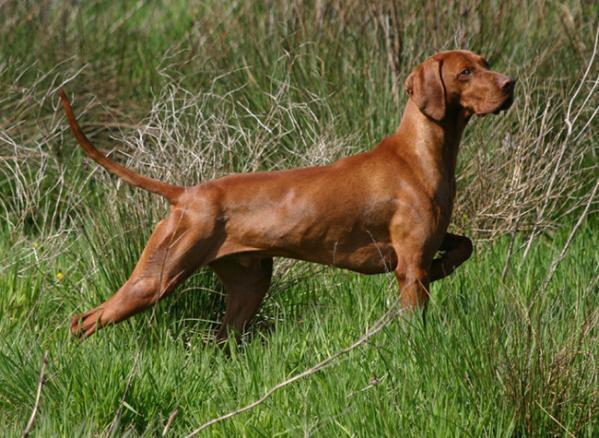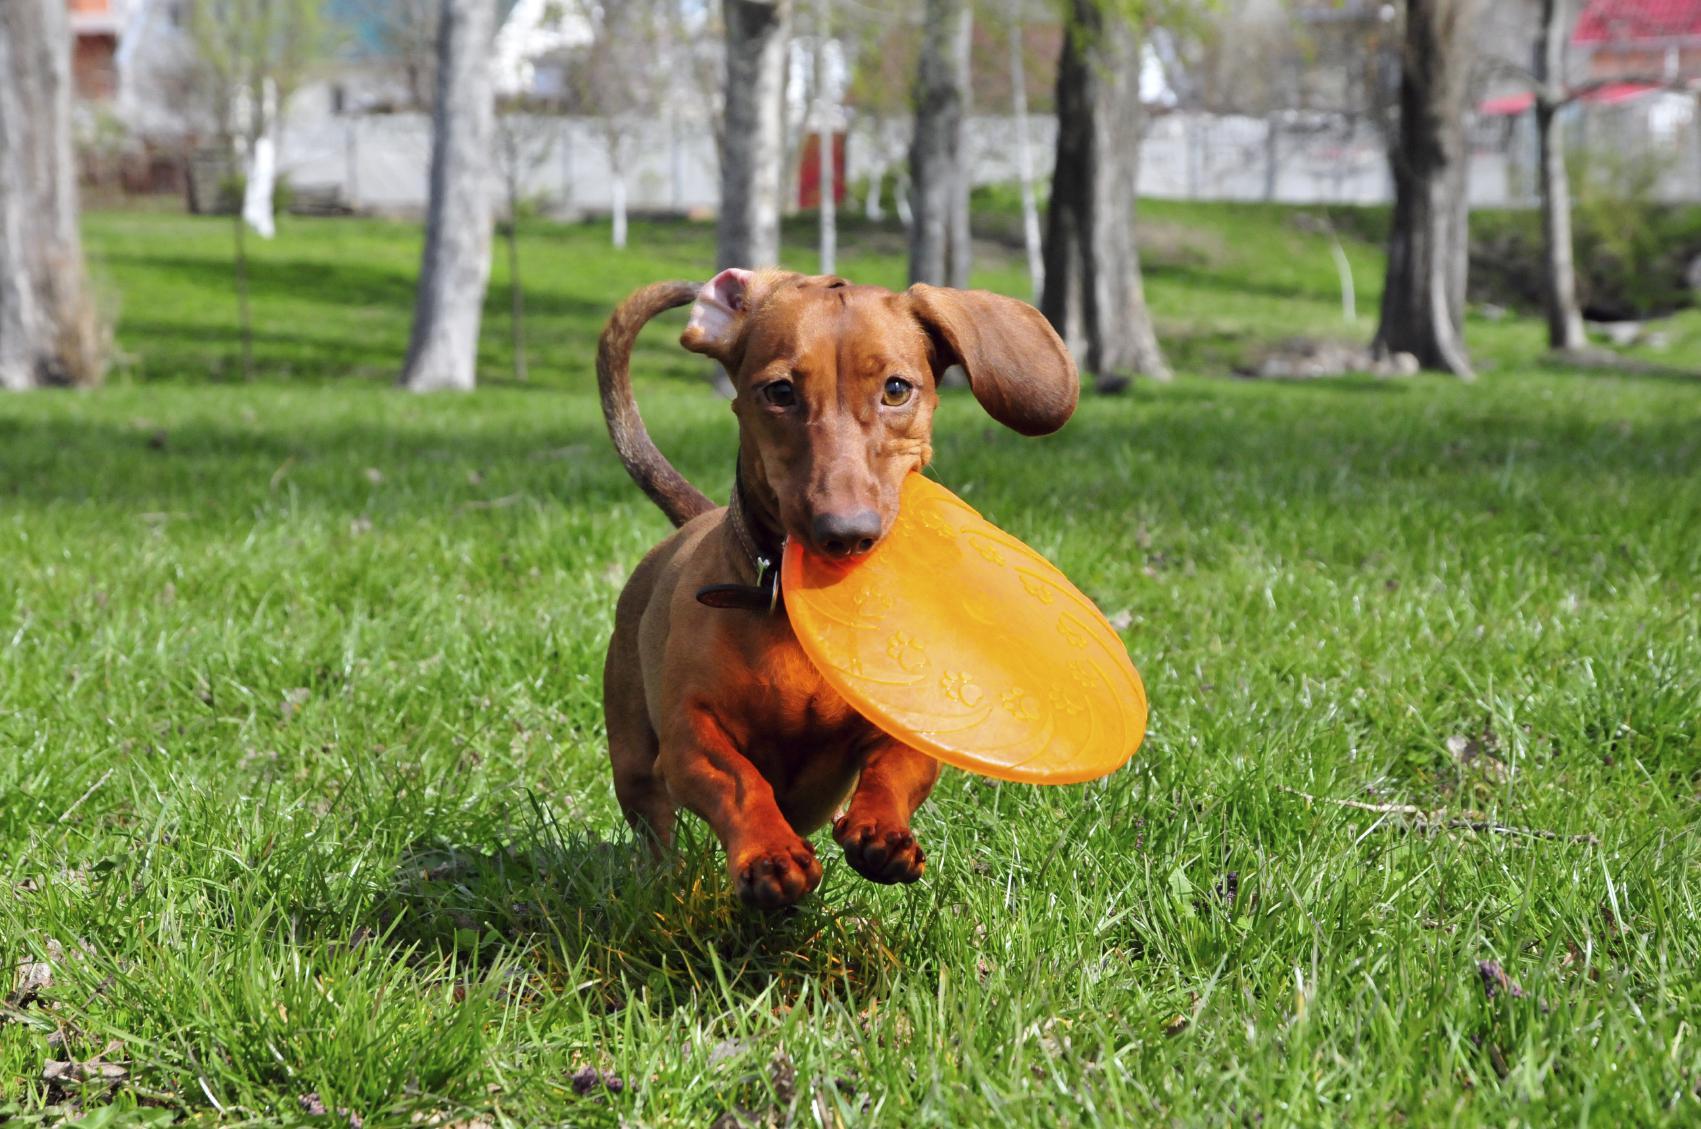The first image is the image on the left, the second image is the image on the right. Analyze the images presented: Is the assertion "One image shows a dog running toward the camera, and the other image shows a dog in a still position gazing rightward." valid? Answer yes or no. Yes. The first image is the image on the left, the second image is the image on the right. Assess this claim about the two images: "There are only two dogs.". Correct or not? Answer yes or no. Yes. 